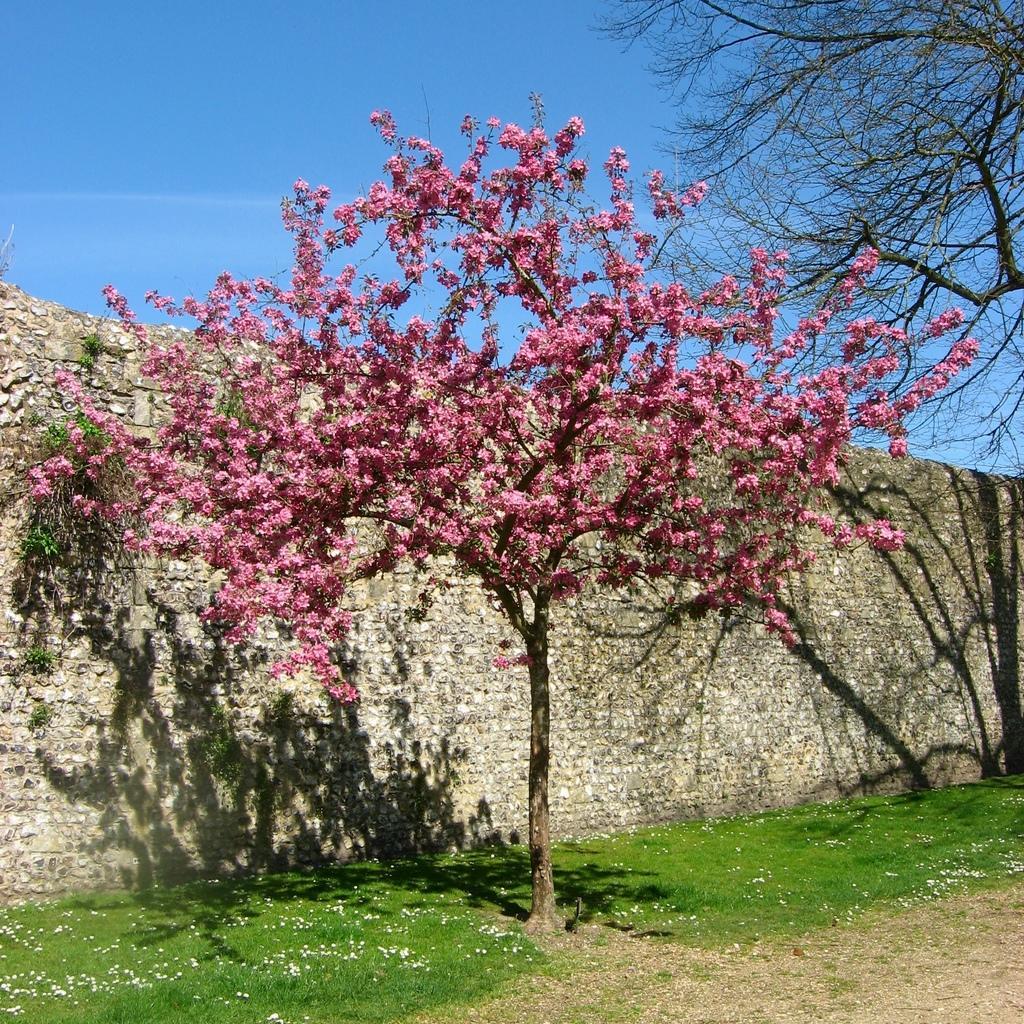In one or two sentences, can you explain what this image depicts? In the foreground of the picture there are flowers, grass, dry grass, and a tree. In the center of the picture there is a wall. On the right there is a tree. Sky is clear and it is sunny. 